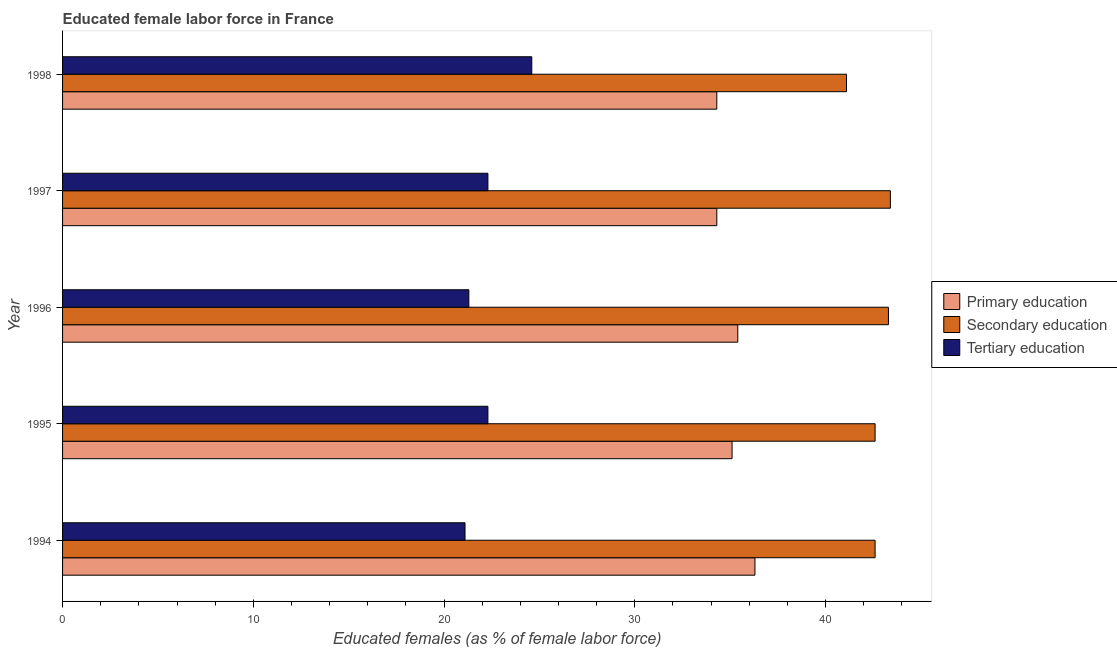How many different coloured bars are there?
Your response must be concise. 3. How many groups of bars are there?
Make the answer very short. 5. Are the number of bars on each tick of the Y-axis equal?
Keep it short and to the point. Yes. What is the label of the 4th group of bars from the top?
Keep it short and to the point. 1995. In how many cases, is the number of bars for a given year not equal to the number of legend labels?
Offer a terse response. 0. What is the percentage of female labor force who received primary education in 1998?
Offer a very short reply. 34.3. Across all years, what is the maximum percentage of female labor force who received secondary education?
Your answer should be compact. 43.4. Across all years, what is the minimum percentage of female labor force who received primary education?
Offer a terse response. 34.3. In which year was the percentage of female labor force who received primary education maximum?
Offer a terse response. 1994. In which year was the percentage of female labor force who received secondary education minimum?
Your response must be concise. 1998. What is the total percentage of female labor force who received primary education in the graph?
Provide a succinct answer. 175.4. What is the difference between the percentage of female labor force who received tertiary education in 1994 and that in 1998?
Make the answer very short. -3.5. What is the difference between the percentage of female labor force who received tertiary education in 1998 and the percentage of female labor force who received primary education in 1996?
Provide a short and direct response. -10.8. What is the average percentage of female labor force who received primary education per year?
Provide a short and direct response. 35.08. In how many years, is the percentage of female labor force who received primary education greater than 20 %?
Your answer should be very brief. 5. What is the ratio of the percentage of female labor force who received primary education in 1995 to that in 1998?
Provide a short and direct response. 1.02. Is the percentage of female labor force who received tertiary education in 1996 less than that in 1997?
Your answer should be very brief. Yes. Is the difference between the percentage of female labor force who received tertiary education in 1995 and 1996 greater than the difference between the percentage of female labor force who received primary education in 1995 and 1996?
Give a very brief answer. Yes. What is the difference between the highest and the lowest percentage of female labor force who received tertiary education?
Offer a very short reply. 3.5. What does the 1st bar from the bottom in 1995 represents?
Ensure brevity in your answer.  Primary education. Is it the case that in every year, the sum of the percentage of female labor force who received primary education and percentage of female labor force who received secondary education is greater than the percentage of female labor force who received tertiary education?
Your answer should be very brief. Yes. Are all the bars in the graph horizontal?
Your response must be concise. Yes. How many years are there in the graph?
Ensure brevity in your answer.  5. What is the difference between two consecutive major ticks on the X-axis?
Make the answer very short. 10. Are the values on the major ticks of X-axis written in scientific E-notation?
Ensure brevity in your answer.  No. Where does the legend appear in the graph?
Make the answer very short. Center right. How are the legend labels stacked?
Make the answer very short. Vertical. What is the title of the graph?
Provide a short and direct response. Educated female labor force in France. What is the label or title of the X-axis?
Provide a succinct answer. Educated females (as % of female labor force). What is the label or title of the Y-axis?
Make the answer very short. Year. What is the Educated females (as % of female labor force) of Primary education in 1994?
Keep it short and to the point. 36.3. What is the Educated females (as % of female labor force) in Secondary education in 1994?
Keep it short and to the point. 42.6. What is the Educated females (as % of female labor force) of Tertiary education in 1994?
Keep it short and to the point. 21.1. What is the Educated females (as % of female labor force) in Primary education in 1995?
Your answer should be compact. 35.1. What is the Educated females (as % of female labor force) of Secondary education in 1995?
Offer a terse response. 42.6. What is the Educated females (as % of female labor force) in Tertiary education in 1995?
Your answer should be very brief. 22.3. What is the Educated females (as % of female labor force) of Primary education in 1996?
Give a very brief answer. 35.4. What is the Educated females (as % of female labor force) of Secondary education in 1996?
Give a very brief answer. 43.3. What is the Educated females (as % of female labor force) of Tertiary education in 1996?
Give a very brief answer. 21.3. What is the Educated females (as % of female labor force) in Primary education in 1997?
Provide a succinct answer. 34.3. What is the Educated females (as % of female labor force) in Secondary education in 1997?
Offer a very short reply. 43.4. What is the Educated females (as % of female labor force) of Tertiary education in 1997?
Ensure brevity in your answer.  22.3. What is the Educated females (as % of female labor force) of Primary education in 1998?
Your answer should be compact. 34.3. What is the Educated females (as % of female labor force) in Secondary education in 1998?
Your answer should be compact. 41.1. What is the Educated females (as % of female labor force) of Tertiary education in 1998?
Keep it short and to the point. 24.6. Across all years, what is the maximum Educated females (as % of female labor force) of Primary education?
Your answer should be very brief. 36.3. Across all years, what is the maximum Educated females (as % of female labor force) in Secondary education?
Give a very brief answer. 43.4. Across all years, what is the maximum Educated females (as % of female labor force) in Tertiary education?
Your response must be concise. 24.6. Across all years, what is the minimum Educated females (as % of female labor force) of Primary education?
Give a very brief answer. 34.3. Across all years, what is the minimum Educated females (as % of female labor force) in Secondary education?
Make the answer very short. 41.1. Across all years, what is the minimum Educated females (as % of female labor force) in Tertiary education?
Keep it short and to the point. 21.1. What is the total Educated females (as % of female labor force) of Primary education in the graph?
Give a very brief answer. 175.4. What is the total Educated females (as % of female labor force) in Secondary education in the graph?
Keep it short and to the point. 213. What is the total Educated females (as % of female labor force) of Tertiary education in the graph?
Keep it short and to the point. 111.6. What is the difference between the Educated females (as % of female labor force) in Secondary education in 1994 and that in 1995?
Offer a very short reply. 0. What is the difference between the Educated females (as % of female labor force) in Primary education in 1994 and that in 1996?
Keep it short and to the point. 0.9. What is the difference between the Educated females (as % of female labor force) in Secondary education in 1994 and that in 1997?
Your response must be concise. -0.8. What is the difference between the Educated females (as % of female labor force) of Primary education in 1994 and that in 1998?
Your answer should be compact. 2. What is the difference between the Educated females (as % of female labor force) in Secondary education in 1994 and that in 1998?
Ensure brevity in your answer.  1.5. What is the difference between the Educated females (as % of female labor force) in Primary education in 1995 and that in 1996?
Your answer should be compact. -0.3. What is the difference between the Educated females (as % of female labor force) in Tertiary education in 1995 and that in 1996?
Offer a very short reply. 1. What is the difference between the Educated females (as % of female labor force) of Primary education in 1995 and that in 1997?
Offer a terse response. 0.8. What is the difference between the Educated females (as % of female labor force) in Secondary education in 1995 and that in 1997?
Offer a very short reply. -0.8. What is the difference between the Educated females (as % of female labor force) of Tertiary education in 1995 and that in 1997?
Offer a terse response. 0. What is the difference between the Educated females (as % of female labor force) of Tertiary education in 1996 and that in 1997?
Give a very brief answer. -1. What is the difference between the Educated females (as % of female labor force) of Secondary education in 1996 and that in 1998?
Make the answer very short. 2.2. What is the difference between the Educated females (as % of female labor force) in Tertiary education in 1996 and that in 1998?
Offer a very short reply. -3.3. What is the difference between the Educated females (as % of female labor force) of Primary education in 1997 and that in 1998?
Make the answer very short. 0. What is the difference between the Educated females (as % of female labor force) of Tertiary education in 1997 and that in 1998?
Offer a very short reply. -2.3. What is the difference between the Educated females (as % of female labor force) in Primary education in 1994 and the Educated females (as % of female labor force) in Tertiary education in 1995?
Offer a terse response. 14. What is the difference between the Educated females (as % of female labor force) of Secondary education in 1994 and the Educated females (as % of female labor force) of Tertiary education in 1995?
Offer a very short reply. 20.3. What is the difference between the Educated females (as % of female labor force) in Secondary education in 1994 and the Educated females (as % of female labor force) in Tertiary education in 1996?
Offer a terse response. 21.3. What is the difference between the Educated females (as % of female labor force) in Primary education in 1994 and the Educated females (as % of female labor force) in Secondary education in 1997?
Ensure brevity in your answer.  -7.1. What is the difference between the Educated females (as % of female labor force) in Primary education in 1994 and the Educated females (as % of female labor force) in Tertiary education in 1997?
Give a very brief answer. 14. What is the difference between the Educated females (as % of female labor force) in Secondary education in 1994 and the Educated females (as % of female labor force) in Tertiary education in 1997?
Provide a short and direct response. 20.3. What is the difference between the Educated females (as % of female labor force) of Primary education in 1994 and the Educated females (as % of female labor force) of Secondary education in 1998?
Offer a very short reply. -4.8. What is the difference between the Educated females (as % of female labor force) of Primary education in 1995 and the Educated females (as % of female labor force) of Secondary education in 1996?
Give a very brief answer. -8.2. What is the difference between the Educated females (as % of female labor force) in Primary education in 1995 and the Educated females (as % of female labor force) in Tertiary education in 1996?
Provide a succinct answer. 13.8. What is the difference between the Educated females (as % of female labor force) in Secondary education in 1995 and the Educated females (as % of female labor force) in Tertiary education in 1996?
Provide a short and direct response. 21.3. What is the difference between the Educated females (as % of female labor force) of Secondary education in 1995 and the Educated females (as % of female labor force) of Tertiary education in 1997?
Your answer should be compact. 20.3. What is the difference between the Educated females (as % of female labor force) of Secondary education in 1995 and the Educated females (as % of female labor force) of Tertiary education in 1998?
Your answer should be very brief. 18. What is the difference between the Educated females (as % of female labor force) of Primary education in 1996 and the Educated females (as % of female labor force) of Tertiary education in 1997?
Keep it short and to the point. 13.1. What is the difference between the Educated females (as % of female labor force) of Primary education in 1996 and the Educated females (as % of female labor force) of Tertiary education in 1998?
Keep it short and to the point. 10.8. What is the difference between the Educated females (as % of female labor force) of Secondary education in 1996 and the Educated females (as % of female labor force) of Tertiary education in 1998?
Provide a succinct answer. 18.7. What is the average Educated females (as % of female labor force) in Primary education per year?
Keep it short and to the point. 35.08. What is the average Educated females (as % of female labor force) in Secondary education per year?
Your answer should be very brief. 42.6. What is the average Educated females (as % of female labor force) in Tertiary education per year?
Ensure brevity in your answer.  22.32. In the year 1994, what is the difference between the Educated females (as % of female labor force) in Secondary education and Educated females (as % of female labor force) in Tertiary education?
Provide a short and direct response. 21.5. In the year 1995, what is the difference between the Educated females (as % of female labor force) in Primary education and Educated females (as % of female labor force) in Secondary education?
Give a very brief answer. -7.5. In the year 1995, what is the difference between the Educated females (as % of female labor force) of Secondary education and Educated females (as % of female labor force) of Tertiary education?
Give a very brief answer. 20.3. In the year 1997, what is the difference between the Educated females (as % of female labor force) of Secondary education and Educated females (as % of female labor force) of Tertiary education?
Provide a short and direct response. 21.1. In the year 1998, what is the difference between the Educated females (as % of female labor force) in Secondary education and Educated females (as % of female labor force) in Tertiary education?
Provide a succinct answer. 16.5. What is the ratio of the Educated females (as % of female labor force) in Primary education in 1994 to that in 1995?
Provide a short and direct response. 1.03. What is the ratio of the Educated females (as % of female labor force) in Secondary education in 1994 to that in 1995?
Offer a very short reply. 1. What is the ratio of the Educated females (as % of female labor force) in Tertiary education in 1994 to that in 1995?
Ensure brevity in your answer.  0.95. What is the ratio of the Educated females (as % of female labor force) of Primary education in 1994 to that in 1996?
Keep it short and to the point. 1.03. What is the ratio of the Educated females (as % of female labor force) of Secondary education in 1994 to that in 1996?
Your answer should be very brief. 0.98. What is the ratio of the Educated females (as % of female labor force) in Tertiary education in 1994 to that in 1996?
Provide a succinct answer. 0.99. What is the ratio of the Educated females (as % of female labor force) in Primary education in 1994 to that in 1997?
Offer a very short reply. 1.06. What is the ratio of the Educated females (as % of female labor force) in Secondary education in 1994 to that in 1997?
Keep it short and to the point. 0.98. What is the ratio of the Educated females (as % of female labor force) in Tertiary education in 1994 to that in 1997?
Provide a succinct answer. 0.95. What is the ratio of the Educated females (as % of female labor force) in Primary education in 1994 to that in 1998?
Make the answer very short. 1.06. What is the ratio of the Educated females (as % of female labor force) in Secondary education in 1994 to that in 1998?
Offer a terse response. 1.04. What is the ratio of the Educated females (as % of female labor force) of Tertiary education in 1994 to that in 1998?
Offer a terse response. 0.86. What is the ratio of the Educated females (as % of female labor force) of Secondary education in 1995 to that in 1996?
Keep it short and to the point. 0.98. What is the ratio of the Educated females (as % of female labor force) in Tertiary education in 1995 to that in 1996?
Give a very brief answer. 1.05. What is the ratio of the Educated females (as % of female labor force) in Primary education in 1995 to that in 1997?
Give a very brief answer. 1.02. What is the ratio of the Educated females (as % of female labor force) in Secondary education in 1995 to that in 1997?
Offer a terse response. 0.98. What is the ratio of the Educated females (as % of female labor force) of Primary education in 1995 to that in 1998?
Ensure brevity in your answer.  1.02. What is the ratio of the Educated females (as % of female labor force) of Secondary education in 1995 to that in 1998?
Your answer should be very brief. 1.04. What is the ratio of the Educated females (as % of female labor force) in Tertiary education in 1995 to that in 1998?
Provide a succinct answer. 0.91. What is the ratio of the Educated females (as % of female labor force) of Primary education in 1996 to that in 1997?
Offer a very short reply. 1.03. What is the ratio of the Educated females (as % of female labor force) of Tertiary education in 1996 to that in 1997?
Provide a short and direct response. 0.96. What is the ratio of the Educated females (as % of female labor force) in Primary education in 1996 to that in 1998?
Offer a very short reply. 1.03. What is the ratio of the Educated females (as % of female labor force) of Secondary education in 1996 to that in 1998?
Keep it short and to the point. 1.05. What is the ratio of the Educated females (as % of female labor force) of Tertiary education in 1996 to that in 1998?
Your response must be concise. 0.87. What is the ratio of the Educated females (as % of female labor force) of Primary education in 1997 to that in 1998?
Offer a very short reply. 1. What is the ratio of the Educated females (as % of female labor force) in Secondary education in 1997 to that in 1998?
Keep it short and to the point. 1.06. What is the ratio of the Educated females (as % of female labor force) in Tertiary education in 1997 to that in 1998?
Your answer should be compact. 0.91. What is the difference between the highest and the second highest Educated females (as % of female labor force) in Primary education?
Make the answer very short. 0.9. What is the difference between the highest and the second highest Educated females (as % of female labor force) in Tertiary education?
Give a very brief answer. 2.3. What is the difference between the highest and the lowest Educated females (as % of female labor force) in Tertiary education?
Your response must be concise. 3.5. 